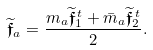<formula> <loc_0><loc_0><loc_500><loc_500>\widetilde { \mathfrak { f } } _ { a } = \frac { m _ { a } \widetilde { \mathfrak { f } } ^ { \, t } _ { 1 } + \bar { m } _ { a } \widetilde { \mathfrak { f } } ^ { \, t } _ { 2 } } { 2 } .</formula> 